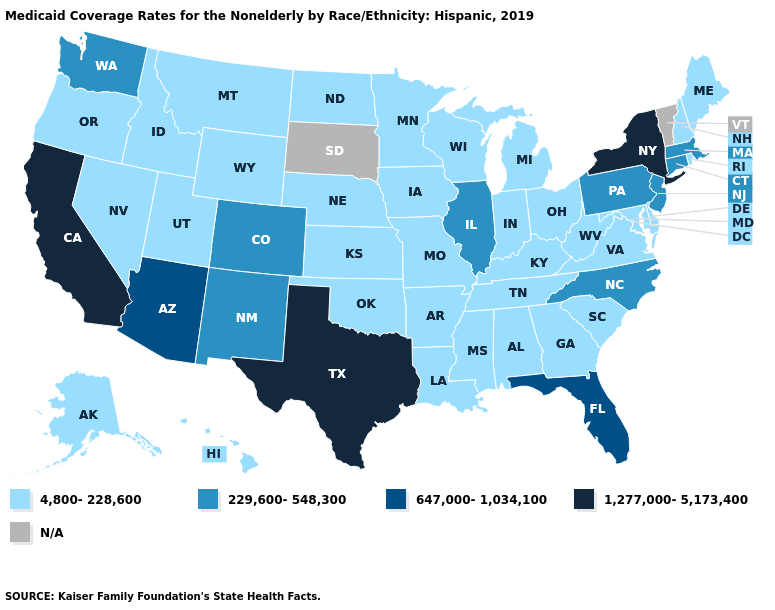What is the value of Idaho?
Answer briefly. 4,800-228,600. Which states have the highest value in the USA?
Concise answer only. California, New York, Texas. Name the states that have a value in the range N/A?
Answer briefly. South Dakota, Vermont. What is the highest value in states that border Georgia?
Short answer required. 647,000-1,034,100. What is the lowest value in the MidWest?
Answer briefly. 4,800-228,600. Does the first symbol in the legend represent the smallest category?
Concise answer only. Yes. What is the highest value in the USA?
Short answer required. 1,277,000-5,173,400. What is the lowest value in states that border Montana?
Quick response, please. 4,800-228,600. Name the states that have a value in the range 1,277,000-5,173,400?
Short answer required. California, New York, Texas. What is the value of Massachusetts?
Give a very brief answer. 229,600-548,300. What is the value of Oregon?
Be succinct. 4,800-228,600. Among the states that border Missouri , which have the highest value?
Short answer required. Illinois. Is the legend a continuous bar?
Be succinct. No. How many symbols are there in the legend?
Write a very short answer. 5. Is the legend a continuous bar?
Give a very brief answer. No. 